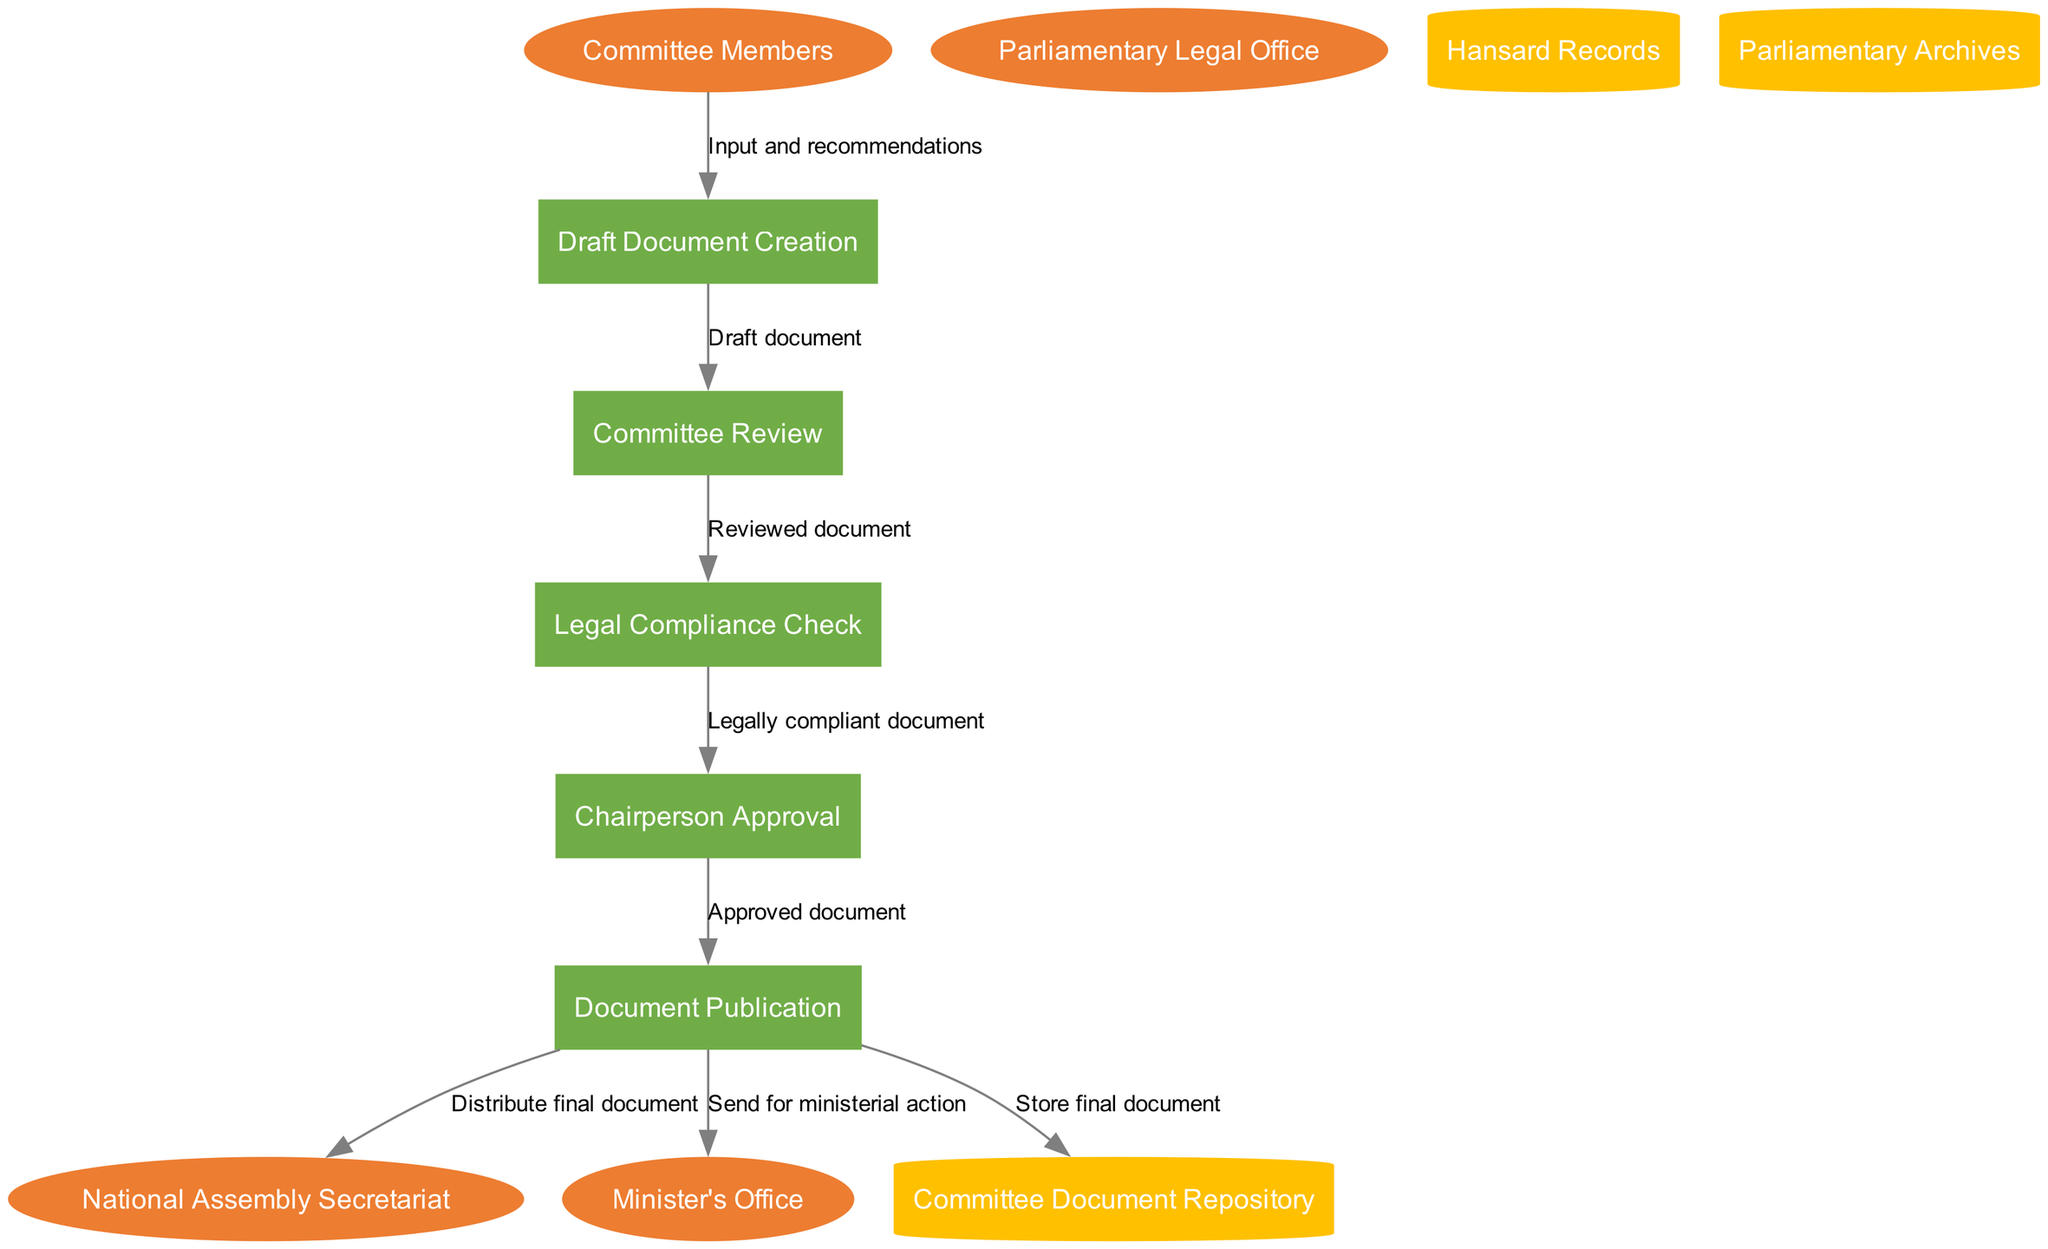What are the external entities in this diagram? The external entities are listed clearly in the diagram, which include Committee Members, Parliamentary Legal Office, National Assembly Secretariat, and Minister's Office.
Answer: Committee Members, Parliamentary Legal Office, National Assembly Secretariat, Minister's Office How many processes are shown in the diagram? The diagram specifies five distinct processes involved in the document routing system: Draft Document Creation, Committee Review, Legal Compliance Check, Chairperson Approval, and Document Publication. Therefore, the count is five.
Answer: Five What does the Committee Members input into the system? According to the data flow, Committee Members provide "Input and recommendations" to the Draft Document Creation process.
Answer: Input and recommendations Which process follows the Legal Compliance Check? The flow indicates that after the Legal Compliance Check process is completed, the next step is Chairperson Approval.
Answer: Chairperson Approval From which process does the final document enter the Committee Document Repository? The diagram indicates that the final document is stored in the Committee Document Repository after being processed in the Document Publication process.
Answer: Document Publication What is the relationship between Committee Review and Legal Compliance Check? The data flow shows that the output from the Committee Review process is a "Reviewed document," which acts as the input for the Legal Compliance Check process.
Answer: Reviewed document Which external entity receives the final document? The final document is distributed to three external entities, among them is the National Assembly Secretariat, as indicated in the data flows from the Document Publication process.
Answer: National Assembly Secretariat How many data stores are present in the diagram? The diagram lists three data stores that are part of the system used for storing documents: Committee Document Repository, Hansard Records, and Parliamentary Archives. Thus, the total number is three.
Answer: Three 